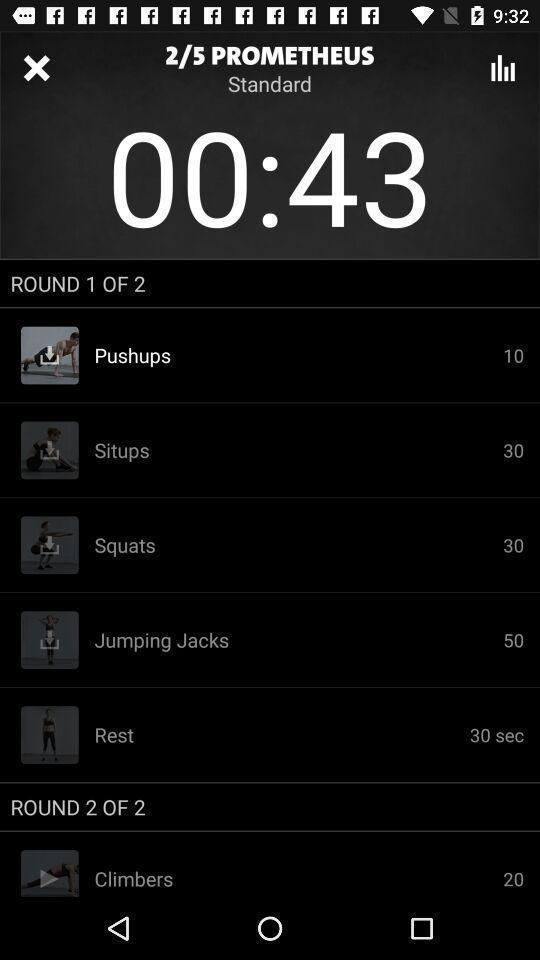Please provide a description for this image. Screen shows multiple options in a fitness application. 